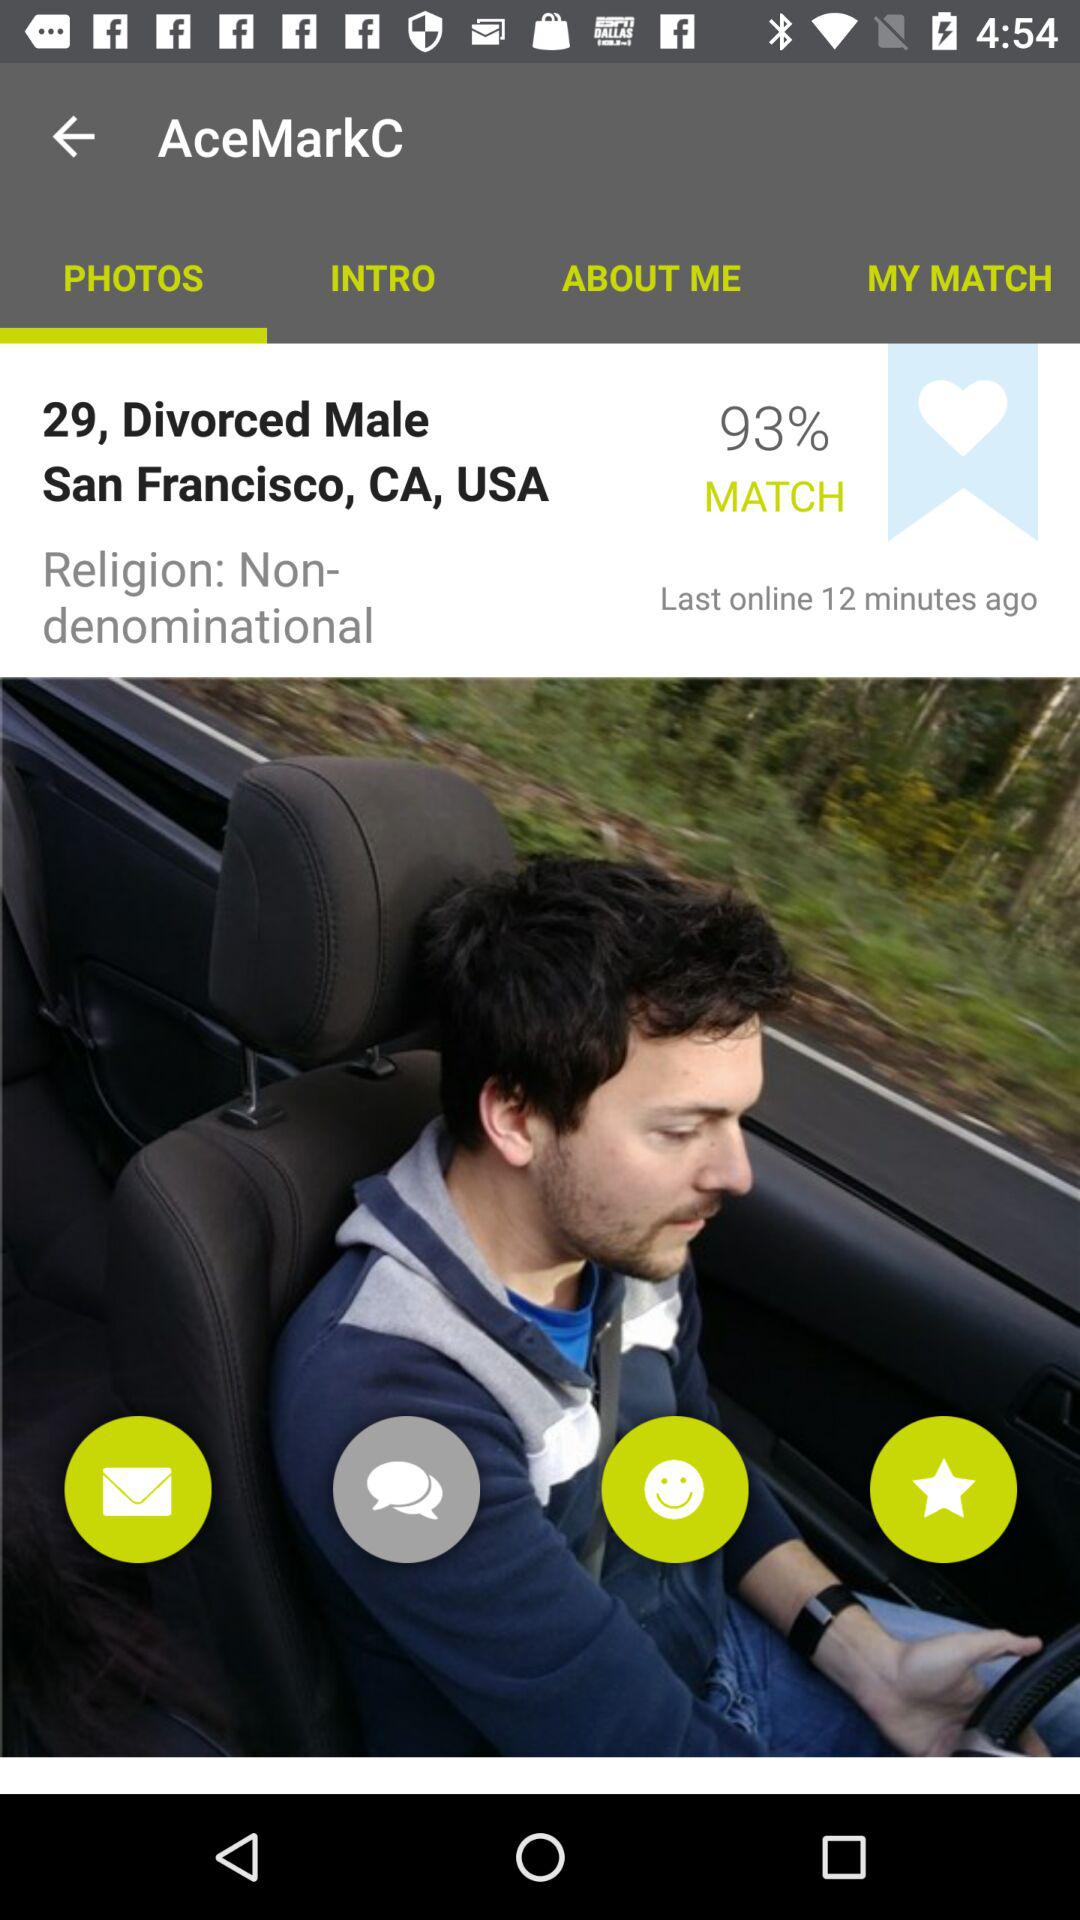What is the given location? The given location is San Francisco, CA, USA. 